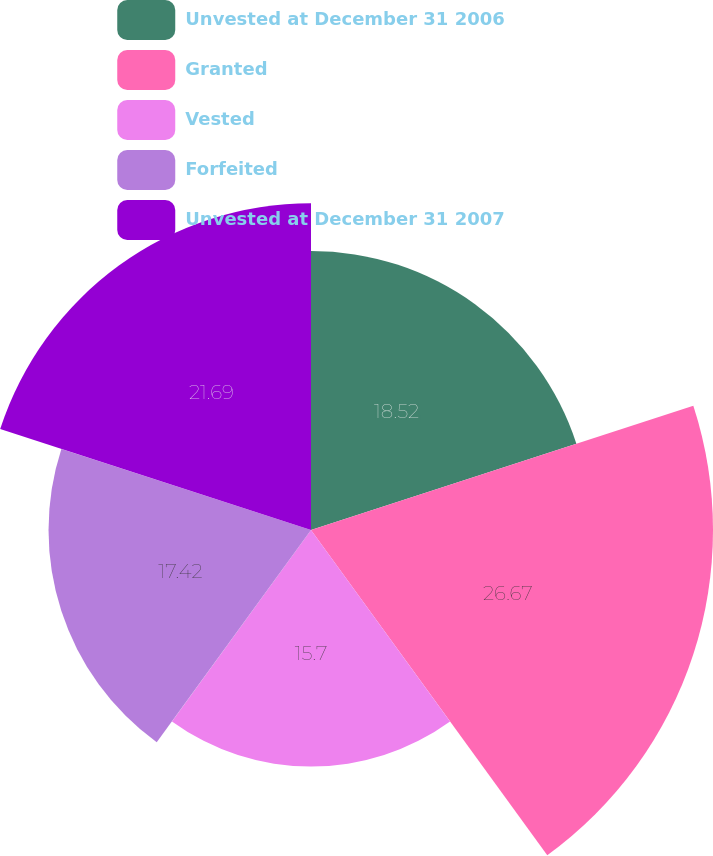Convert chart. <chart><loc_0><loc_0><loc_500><loc_500><pie_chart><fcel>Unvested at December 31 2006<fcel>Granted<fcel>Vested<fcel>Forfeited<fcel>Unvested at December 31 2007<nl><fcel>18.52%<fcel>26.68%<fcel>15.7%<fcel>17.42%<fcel>21.69%<nl></chart> 